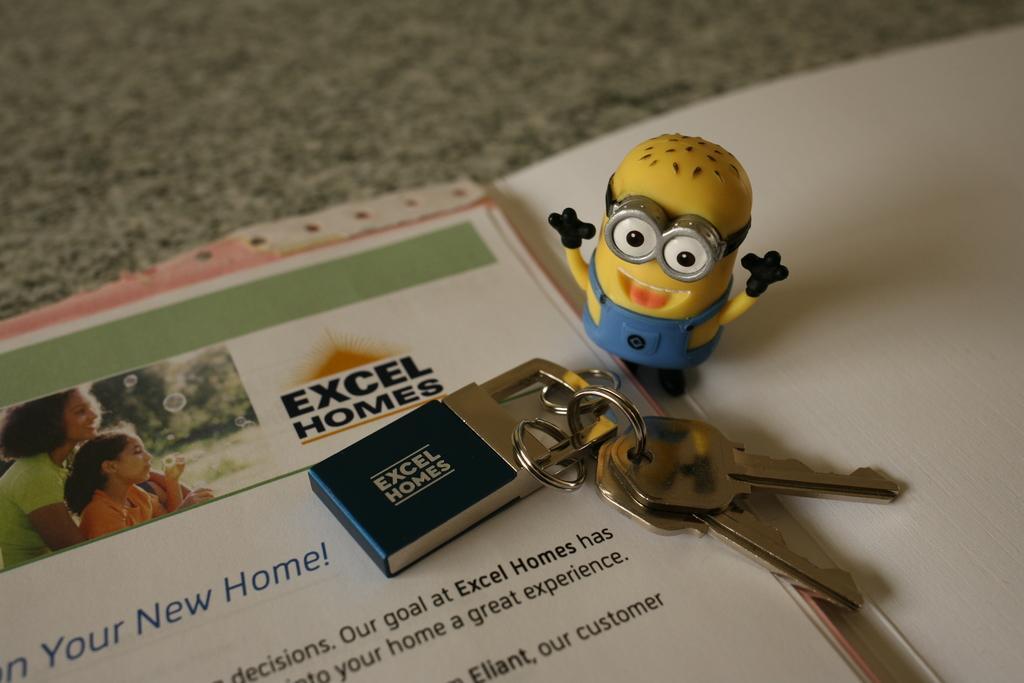Could you give a brief overview of what you see in this image? In this image I can see a toy in yellow and blue color and I can see few keys and few papers on the gray color surface. In the paper I can see two persons sitting and I can see something written on the paper. 